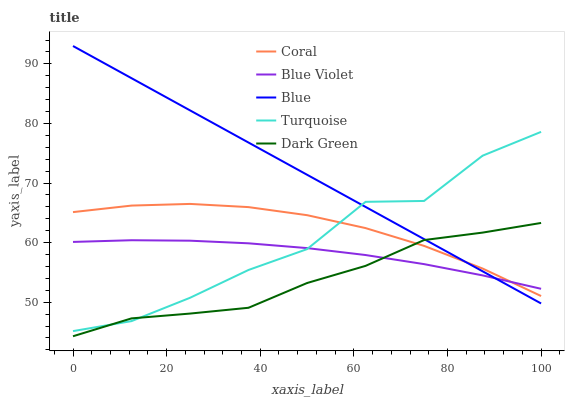Does Dark Green have the minimum area under the curve?
Answer yes or no. Yes. Does Blue have the maximum area under the curve?
Answer yes or no. Yes. Does Coral have the minimum area under the curve?
Answer yes or no. No. Does Coral have the maximum area under the curve?
Answer yes or no. No. Is Blue the smoothest?
Answer yes or no. Yes. Is Turquoise the roughest?
Answer yes or no. Yes. Is Coral the smoothest?
Answer yes or no. No. Is Coral the roughest?
Answer yes or no. No. Does Coral have the lowest value?
Answer yes or no. No. Does Coral have the highest value?
Answer yes or no. No. 